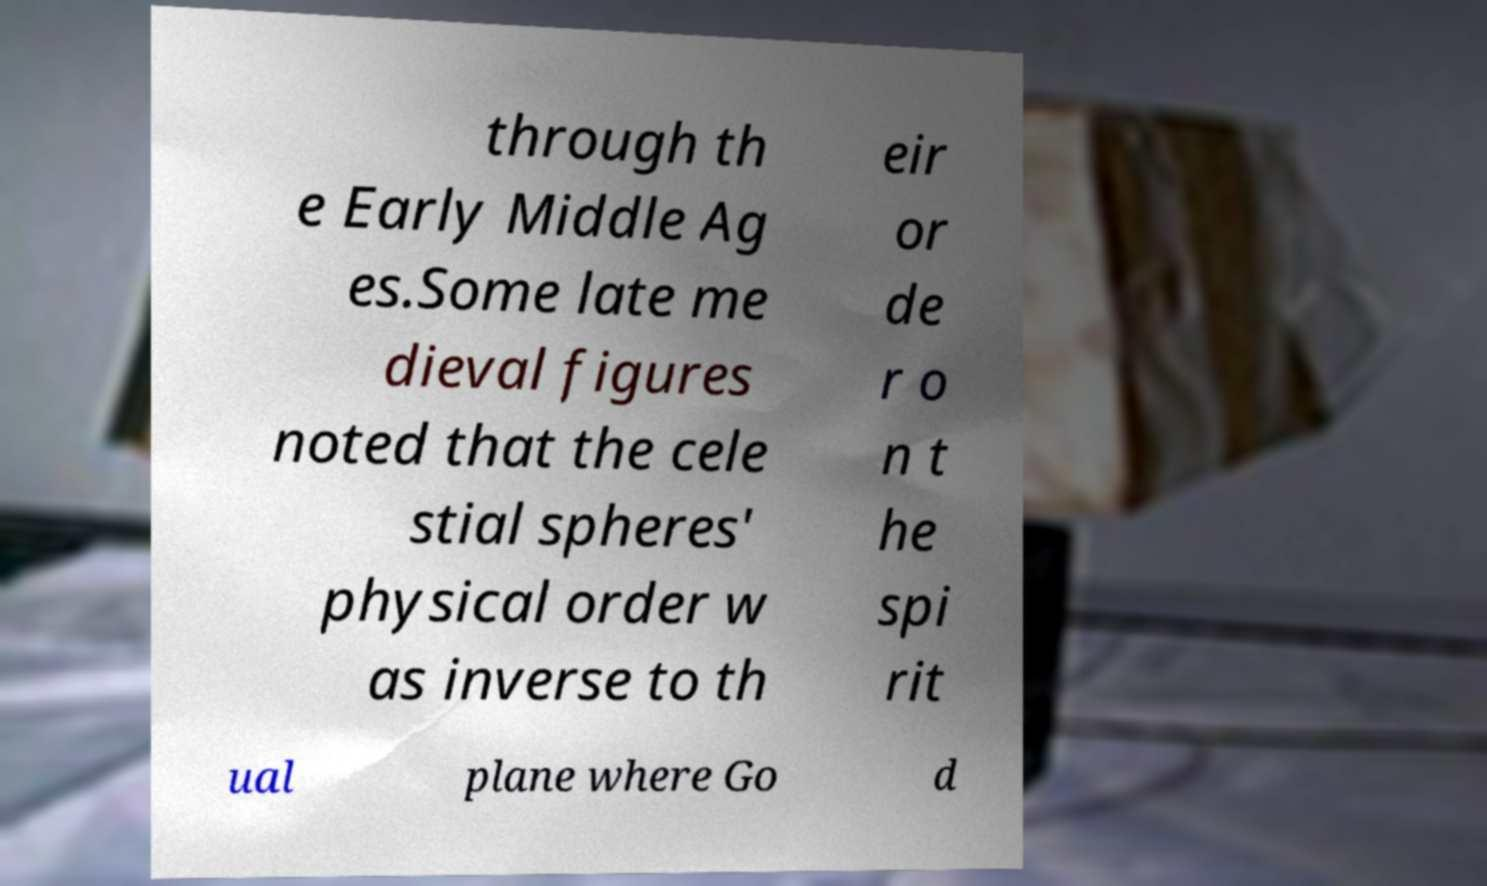Could you assist in decoding the text presented in this image and type it out clearly? through th e Early Middle Ag es.Some late me dieval figures noted that the cele stial spheres' physical order w as inverse to th eir or de r o n t he spi rit ual plane where Go d 